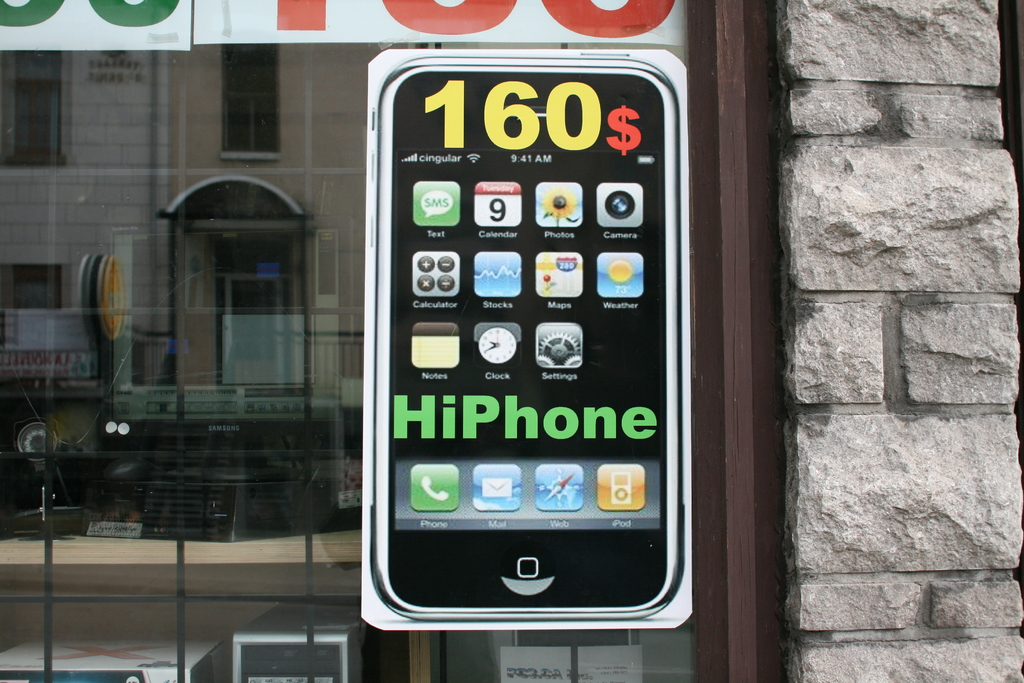What features are showcased on the phone in the advertisement? The phone in the advertisement highlights features such as SMS, Calendar, Photos, Camera, Maps, Weather, Settings, Stocks, iPod, and Calculator. 